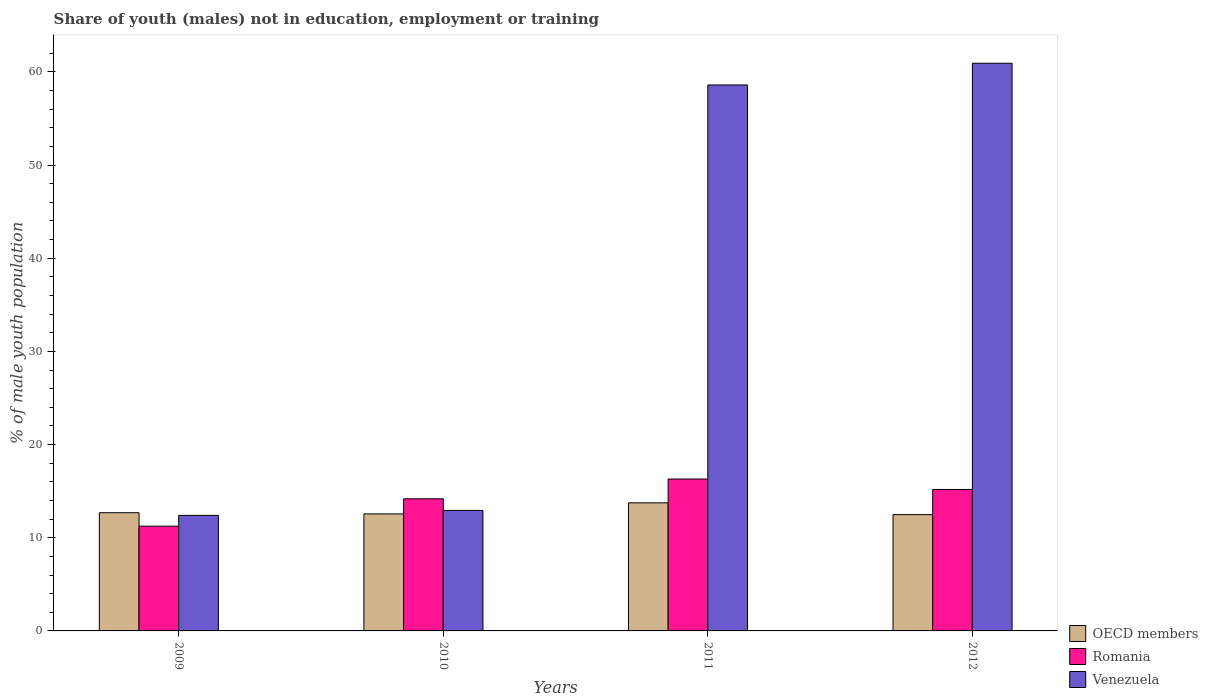Are the number of bars on each tick of the X-axis equal?
Ensure brevity in your answer.  Yes. In how many cases, is the number of bars for a given year not equal to the number of legend labels?
Your answer should be very brief. 0. What is the percentage of unemployed males population in in Venezuela in 2012?
Your answer should be very brief. 60.92. Across all years, what is the maximum percentage of unemployed males population in in Venezuela?
Offer a very short reply. 60.92. Across all years, what is the minimum percentage of unemployed males population in in OECD members?
Your answer should be compact. 12.48. In which year was the percentage of unemployed males population in in Romania maximum?
Provide a succinct answer. 2011. What is the total percentage of unemployed males population in in Romania in the graph?
Keep it short and to the point. 56.9. What is the difference between the percentage of unemployed males population in in Romania in 2009 and that in 2012?
Make the answer very short. -3.94. What is the difference between the percentage of unemployed males population in in OECD members in 2009 and the percentage of unemployed males population in in Venezuela in 2012?
Your answer should be compact. -48.23. What is the average percentage of unemployed males population in in Venezuela per year?
Your response must be concise. 36.21. In the year 2012, what is the difference between the percentage of unemployed males population in in Romania and percentage of unemployed males population in in Venezuela?
Your response must be concise. -45.74. What is the ratio of the percentage of unemployed males population in in OECD members in 2010 to that in 2011?
Give a very brief answer. 0.91. Is the percentage of unemployed males population in in Romania in 2009 less than that in 2011?
Your answer should be compact. Yes. Is the difference between the percentage of unemployed males population in in Romania in 2009 and 2012 greater than the difference between the percentage of unemployed males population in in Venezuela in 2009 and 2012?
Keep it short and to the point. Yes. What is the difference between the highest and the second highest percentage of unemployed males population in in OECD members?
Your response must be concise. 1.06. What is the difference between the highest and the lowest percentage of unemployed males population in in Romania?
Offer a very short reply. 5.06. In how many years, is the percentage of unemployed males population in in Venezuela greater than the average percentage of unemployed males population in in Venezuela taken over all years?
Keep it short and to the point. 2. Is the sum of the percentage of unemployed males population in in Romania in 2009 and 2010 greater than the maximum percentage of unemployed males population in in Venezuela across all years?
Your answer should be compact. No. What does the 2nd bar from the left in 2009 represents?
Provide a succinct answer. Romania. What does the 2nd bar from the right in 2012 represents?
Your response must be concise. Romania. How many bars are there?
Offer a very short reply. 12. Are all the bars in the graph horizontal?
Make the answer very short. No. What is the difference between two consecutive major ticks on the Y-axis?
Keep it short and to the point. 10. Does the graph contain any zero values?
Your answer should be very brief. No. Does the graph contain grids?
Your answer should be very brief. No. What is the title of the graph?
Your answer should be very brief. Share of youth (males) not in education, employment or training. Does "Niger" appear as one of the legend labels in the graph?
Your response must be concise. No. What is the label or title of the X-axis?
Offer a very short reply. Years. What is the label or title of the Y-axis?
Your answer should be very brief. % of male youth population. What is the % of male youth population of OECD members in 2009?
Offer a terse response. 12.69. What is the % of male youth population in Romania in 2009?
Give a very brief answer. 11.24. What is the % of male youth population of Venezuela in 2009?
Your response must be concise. 12.4. What is the % of male youth population in OECD members in 2010?
Your answer should be very brief. 12.56. What is the % of male youth population of Romania in 2010?
Provide a succinct answer. 14.18. What is the % of male youth population of Venezuela in 2010?
Offer a very short reply. 12.93. What is the % of male youth population in OECD members in 2011?
Your answer should be very brief. 13.74. What is the % of male youth population in Romania in 2011?
Your response must be concise. 16.3. What is the % of male youth population in Venezuela in 2011?
Provide a short and direct response. 58.59. What is the % of male youth population in OECD members in 2012?
Offer a very short reply. 12.48. What is the % of male youth population of Romania in 2012?
Provide a short and direct response. 15.18. What is the % of male youth population of Venezuela in 2012?
Offer a very short reply. 60.92. Across all years, what is the maximum % of male youth population in OECD members?
Provide a succinct answer. 13.74. Across all years, what is the maximum % of male youth population in Romania?
Provide a succinct answer. 16.3. Across all years, what is the maximum % of male youth population in Venezuela?
Ensure brevity in your answer.  60.92. Across all years, what is the minimum % of male youth population of OECD members?
Keep it short and to the point. 12.48. Across all years, what is the minimum % of male youth population in Romania?
Give a very brief answer. 11.24. Across all years, what is the minimum % of male youth population in Venezuela?
Ensure brevity in your answer.  12.4. What is the total % of male youth population in OECD members in the graph?
Make the answer very short. 51.47. What is the total % of male youth population of Romania in the graph?
Give a very brief answer. 56.9. What is the total % of male youth population of Venezuela in the graph?
Your response must be concise. 144.84. What is the difference between the % of male youth population in OECD members in 2009 and that in 2010?
Make the answer very short. 0.13. What is the difference between the % of male youth population of Romania in 2009 and that in 2010?
Give a very brief answer. -2.94. What is the difference between the % of male youth population in Venezuela in 2009 and that in 2010?
Your response must be concise. -0.53. What is the difference between the % of male youth population in OECD members in 2009 and that in 2011?
Keep it short and to the point. -1.06. What is the difference between the % of male youth population of Romania in 2009 and that in 2011?
Make the answer very short. -5.06. What is the difference between the % of male youth population in Venezuela in 2009 and that in 2011?
Make the answer very short. -46.19. What is the difference between the % of male youth population of OECD members in 2009 and that in 2012?
Your response must be concise. 0.21. What is the difference between the % of male youth population in Romania in 2009 and that in 2012?
Ensure brevity in your answer.  -3.94. What is the difference between the % of male youth population of Venezuela in 2009 and that in 2012?
Provide a succinct answer. -48.52. What is the difference between the % of male youth population in OECD members in 2010 and that in 2011?
Ensure brevity in your answer.  -1.18. What is the difference between the % of male youth population in Romania in 2010 and that in 2011?
Offer a terse response. -2.12. What is the difference between the % of male youth population in Venezuela in 2010 and that in 2011?
Ensure brevity in your answer.  -45.66. What is the difference between the % of male youth population in OECD members in 2010 and that in 2012?
Your answer should be compact. 0.08. What is the difference between the % of male youth population of Venezuela in 2010 and that in 2012?
Ensure brevity in your answer.  -47.99. What is the difference between the % of male youth population in OECD members in 2011 and that in 2012?
Offer a terse response. 1.26. What is the difference between the % of male youth population in Romania in 2011 and that in 2012?
Your answer should be very brief. 1.12. What is the difference between the % of male youth population of Venezuela in 2011 and that in 2012?
Keep it short and to the point. -2.33. What is the difference between the % of male youth population of OECD members in 2009 and the % of male youth population of Romania in 2010?
Offer a very short reply. -1.49. What is the difference between the % of male youth population of OECD members in 2009 and the % of male youth population of Venezuela in 2010?
Your answer should be compact. -0.24. What is the difference between the % of male youth population in Romania in 2009 and the % of male youth population in Venezuela in 2010?
Provide a succinct answer. -1.69. What is the difference between the % of male youth population of OECD members in 2009 and the % of male youth population of Romania in 2011?
Give a very brief answer. -3.61. What is the difference between the % of male youth population of OECD members in 2009 and the % of male youth population of Venezuela in 2011?
Your response must be concise. -45.9. What is the difference between the % of male youth population of Romania in 2009 and the % of male youth population of Venezuela in 2011?
Your answer should be very brief. -47.35. What is the difference between the % of male youth population of OECD members in 2009 and the % of male youth population of Romania in 2012?
Give a very brief answer. -2.49. What is the difference between the % of male youth population in OECD members in 2009 and the % of male youth population in Venezuela in 2012?
Your answer should be very brief. -48.23. What is the difference between the % of male youth population of Romania in 2009 and the % of male youth population of Venezuela in 2012?
Keep it short and to the point. -49.68. What is the difference between the % of male youth population of OECD members in 2010 and the % of male youth population of Romania in 2011?
Provide a short and direct response. -3.74. What is the difference between the % of male youth population of OECD members in 2010 and the % of male youth population of Venezuela in 2011?
Your answer should be very brief. -46.03. What is the difference between the % of male youth population in Romania in 2010 and the % of male youth population in Venezuela in 2011?
Provide a succinct answer. -44.41. What is the difference between the % of male youth population in OECD members in 2010 and the % of male youth population in Romania in 2012?
Your answer should be compact. -2.62. What is the difference between the % of male youth population in OECD members in 2010 and the % of male youth population in Venezuela in 2012?
Provide a short and direct response. -48.36. What is the difference between the % of male youth population of Romania in 2010 and the % of male youth population of Venezuela in 2012?
Keep it short and to the point. -46.74. What is the difference between the % of male youth population of OECD members in 2011 and the % of male youth population of Romania in 2012?
Your answer should be compact. -1.44. What is the difference between the % of male youth population in OECD members in 2011 and the % of male youth population in Venezuela in 2012?
Your answer should be very brief. -47.18. What is the difference between the % of male youth population of Romania in 2011 and the % of male youth population of Venezuela in 2012?
Keep it short and to the point. -44.62. What is the average % of male youth population in OECD members per year?
Provide a short and direct response. 12.87. What is the average % of male youth population of Romania per year?
Make the answer very short. 14.22. What is the average % of male youth population of Venezuela per year?
Provide a succinct answer. 36.21. In the year 2009, what is the difference between the % of male youth population in OECD members and % of male youth population in Romania?
Your answer should be compact. 1.45. In the year 2009, what is the difference between the % of male youth population of OECD members and % of male youth population of Venezuela?
Your answer should be very brief. 0.29. In the year 2009, what is the difference between the % of male youth population in Romania and % of male youth population in Venezuela?
Give a very brief answer. -1.16. In the year 2010, what is the difference between the % of male youth population in OECD members and % of male youth population in Romania?
Give a very brief answer. -1.62. In the year 2010, what is the difference between the % of male youth population in OECD members and % of male youth population in Venezuela?
Make the answer very short. -0.37. In the year 2010, what is the difference between the % of male youth population in Romania and % of male youth population in Venezuela?
Make the answer very short. 1.25. In the year 2011, what is the difference between the % of male youth population in OECD members and % of male youth population in Romania?
Keep it short and to the point. -2.56. In the year 2011, what is the difference between the % of male youth population in OECD members and % of male youth population in Venezuela?
Make the answer very short. -44.85. In the year 2011, what is the difference between the % of male youth population in Romania and % of male youth population in Venezuela?
Give a very brief answer. -42.29. In the year 2012, what is the difference between the % of male youth population of OECD members and % of male youth population of Romania?
Provide a short and direct response. -2.7. In the year 2012, what is the difference between the % of male youth population in OECD members and % of male youth population in Venezuela?
Make the answer very short. -48.44. In the year 2012, what is the difference between the % of male youth population in Romania and % of male youth population in Venezuela?
Provide a short and direct response. -45.74. What is the ratio of the % of male youth population of OECD members in 2009 to that in 2010?
Your answer should be very brief. 1.01. What is the ratio of the % of male youth population in Romania in 2009 to that in 2010?
Offer a terse response. 0.79. What is the ratio of the % of male youth population in OECD members in 2009 to that in 2011?
Offer a very short reply. 0.92. What is the ratio of the % of male youth population of Romania in 2009 to that in 2011?
Offer a very short reply. 0.69. What is the ratio of the % of male youth population in Venezuela in 2009 to that in 2011?
Offer a very short reply. 0.21. What is the ratio of the % of male youth population in OECD members in 2009 to that in 2012?
Provide a short and direct response. 1.02. What is the ratio of the % of male youth population of Romania in 2009 to that in 2012?
Offer a very short reply. 0.74. What is the ratio of the % of male youth population in Venezuela in 2009 to that in 2012?
Keep it short and to the point. 0.2. What is the ratio of the % of male youth population in OECD members in 2010 to that in 2011?
Your response must be concise. 0.91. What is the ratio of the % of male youth population of Romania in 2010 to that in 2011?
Ensure brevity in your answer.  0.87. What is the ratio of the % of male youth population in Venezuela in 2010 to that in 2011?
Keep it short and to the point. 0.22. What is the ratio of the % of male youth population in OECD members in 2010 to that in 2012?
Make the answer very short. 1.01. What is the ratio of the % of male youth population in Romania in 2010 to that in 2012?
Provide a short and direct response. 0.93. What is the ratio of the % of male youth population in Venezuela in 2010 to that in 2012?
Provide a short and direct response. 0.21. What is the ratio of the % of male youth population of OECD members in 2011 to that in 2012?
Provide a succinct answer. 1.1. What is the ratio of the % of male youth population of Romania in 2011 to that in 2012?
Make the answer very short. 1.07. What is the ratio of the % of male youth population in Venezuela in 2011 to that in 2012?
Give a very brief answer. 0.96. What is the difference between the highest and the second highest % of male youth population of OECD members?
Offer a terse response. 1.06. What is the difference between the highest and the second highest % of male youth population of Romania?
Your answer should be very brief. 1.12. What is the difference between the highest and the second highest % of male youth population of Venezuela?
Provide a short and direct response. 2.33. What is the difference between the highest and the lowest % of male youth population in OECD members?
Ensure brevity in your answer.  1.26. What is the difference between the highest and the lowest % of male youth population of Romania?
Your answer should be very brief. 5.06. What is the difference between the highest and the lowest % of male youth population in Venezuela?
Give a very brief answer. 48.52. 